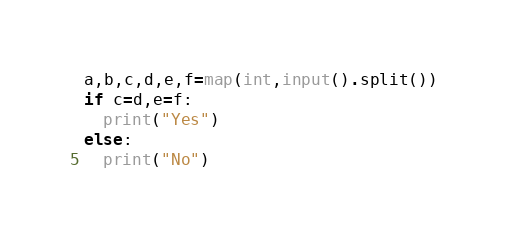Convert code to text. <code><loc_0><loc_0><loc_500><loc_500><_Python_>a,b,c,d,e,f=map(int,input().split())
if c=d,e=f:
  print("Yes")
else:
  print("No")</code> 